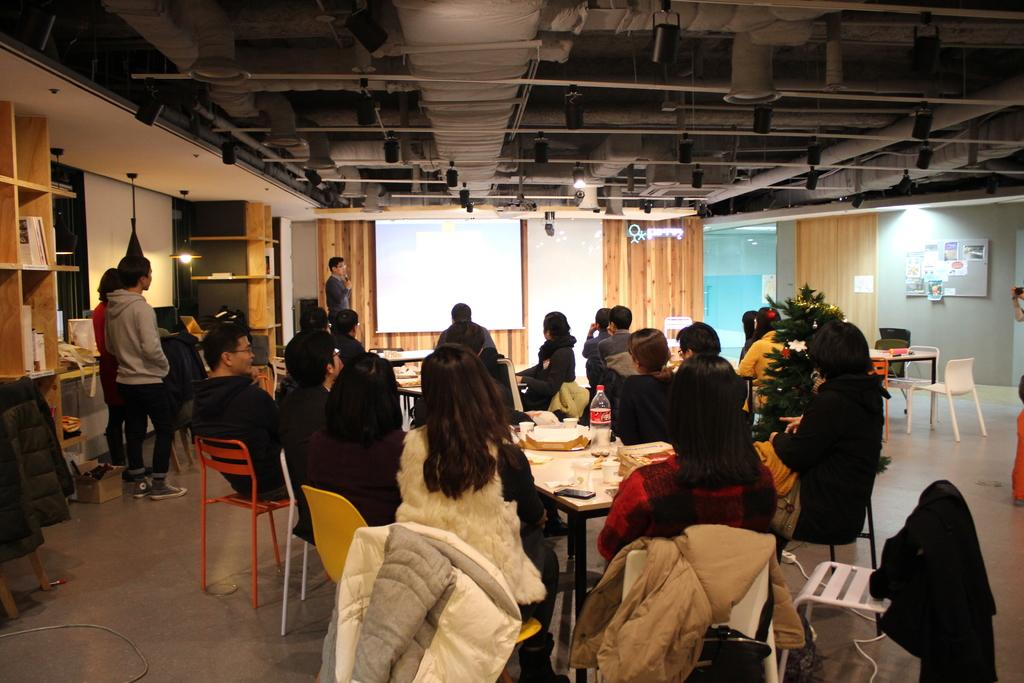How many people are in the image? There are multiple people in the image. What are the majority of people doing in the image? Most of the people are sitting. Are there any people standing in the image? Yes, some people are standing. What can be seen in the background of the image? There is a wall, racks, and lights in the background of the image. What type of frame is being used by the people to swim in the image? There is no frame or swimming activity present in the image. 